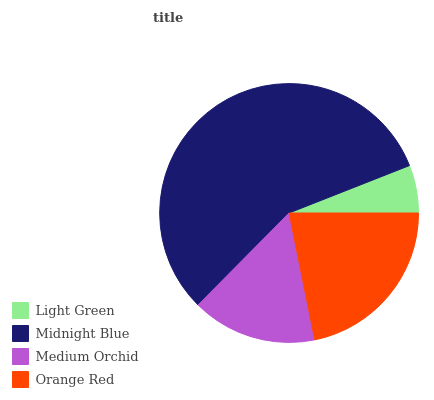Is Light Green the minimum?
Answer yes or no. Yes. Is Midnight Blue the maximum?
Answer yes or no. Yes. Is Medium Orchid the minimum?
Answer yes or no. No. Is Medium Orchid the maximum?
Answer yes or no. No. Is Midnight Blue greater than Medium Orchid?
Answer yes or no. Yes. Is Medium Orchid less than Midnight Blue?
Answer yes or no. Yes. Is Medium Orchid greater than Midnight Blue?
Answer yes or no. No. Is Midnight Blue less than Medium Orchid?
Answer yes or no. No. Is Orange Red the high median?
Answer yes or no. Yes. Is Medium Orchid the low median?
Answer yes or no. Yes. Is Medium Orchid the high median?
Answer yes or no. No. Is Orange Red the low median?
Answer yes or no. No. 